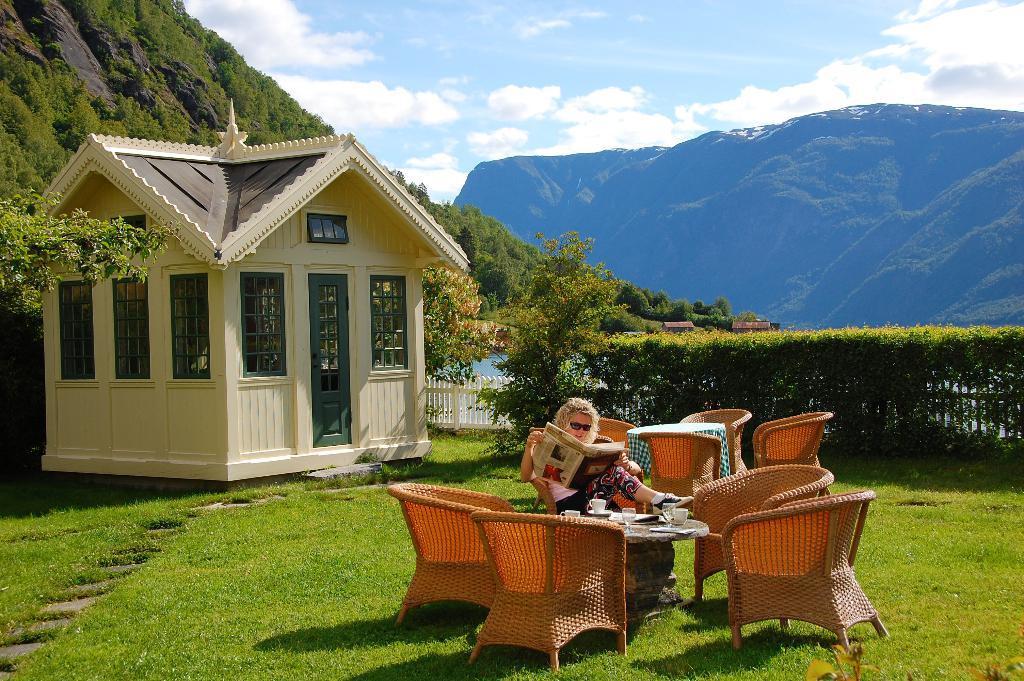In one or two sentences, can you explain what this image depicts? In this image in the front there's grass on the ground. In the center there are empty chairs and there is a person sitting on the chair and reading a newspaper and in the front of the person there is a table and on the table, there is a cup and there is a paper. In the background there are plants, there is a house and there are trees and there are mountains and the sky is cloudy. 